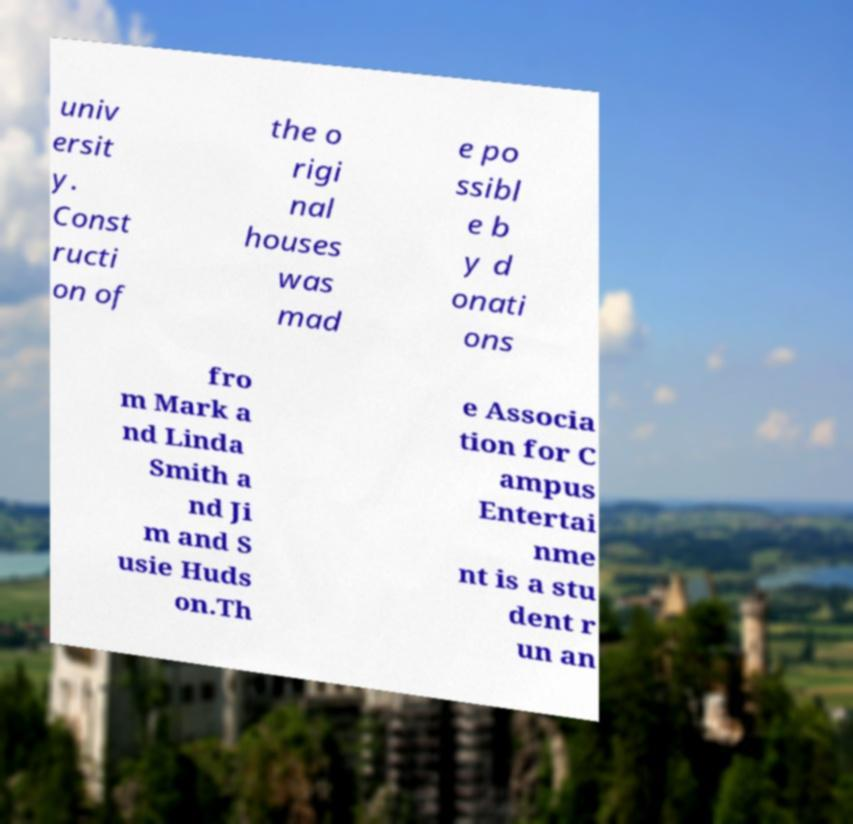I need the written content from this picture converted into text. Can you do that? univ ersit y. Const ructi on of the o rigi nal houses was mad e po ssibl e b y d onati ons fro m Mark a nd Linda Smith a nd Ji m and S usie Huds on.Th e Associa tion for C ampus Entertai nme nt is a stu dent r un an 